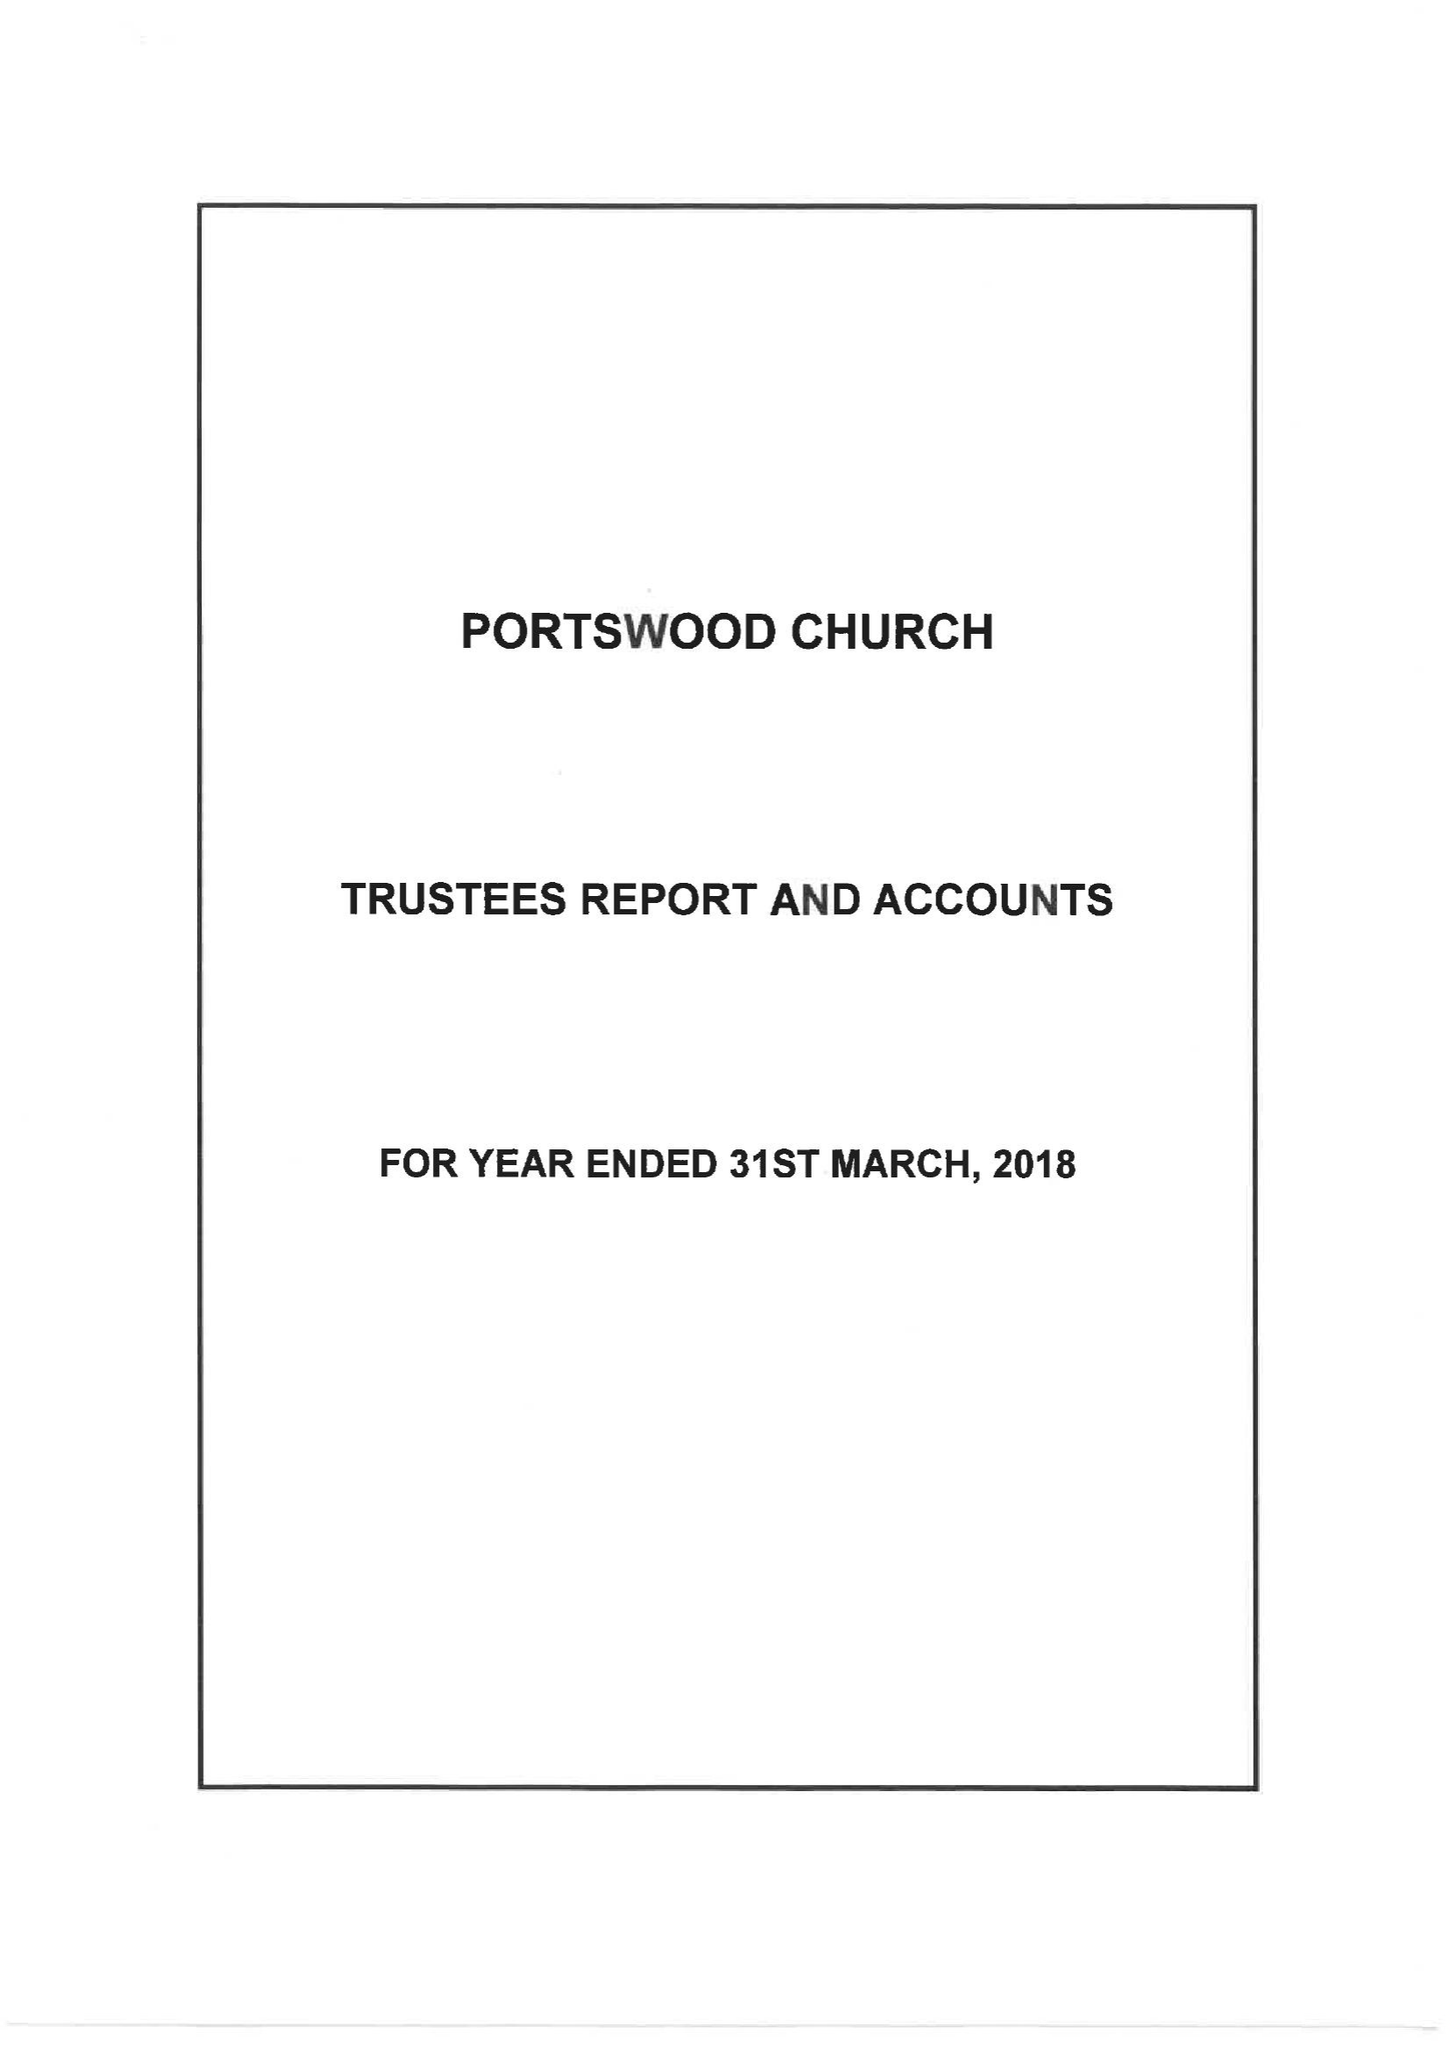What is the value for the address__street_line?
Answer the question using a single word or phrase. PORTSWOOD ROAD 